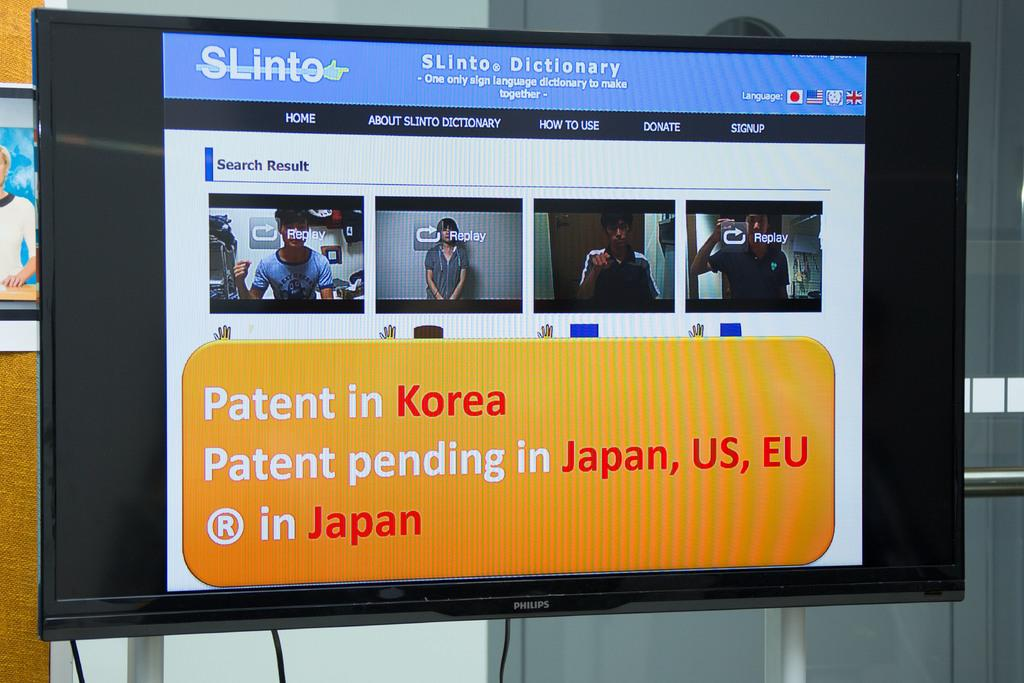<image>
Render a clear and concise summary of the photo. A computer search page about patents pending in Korea and Japan 